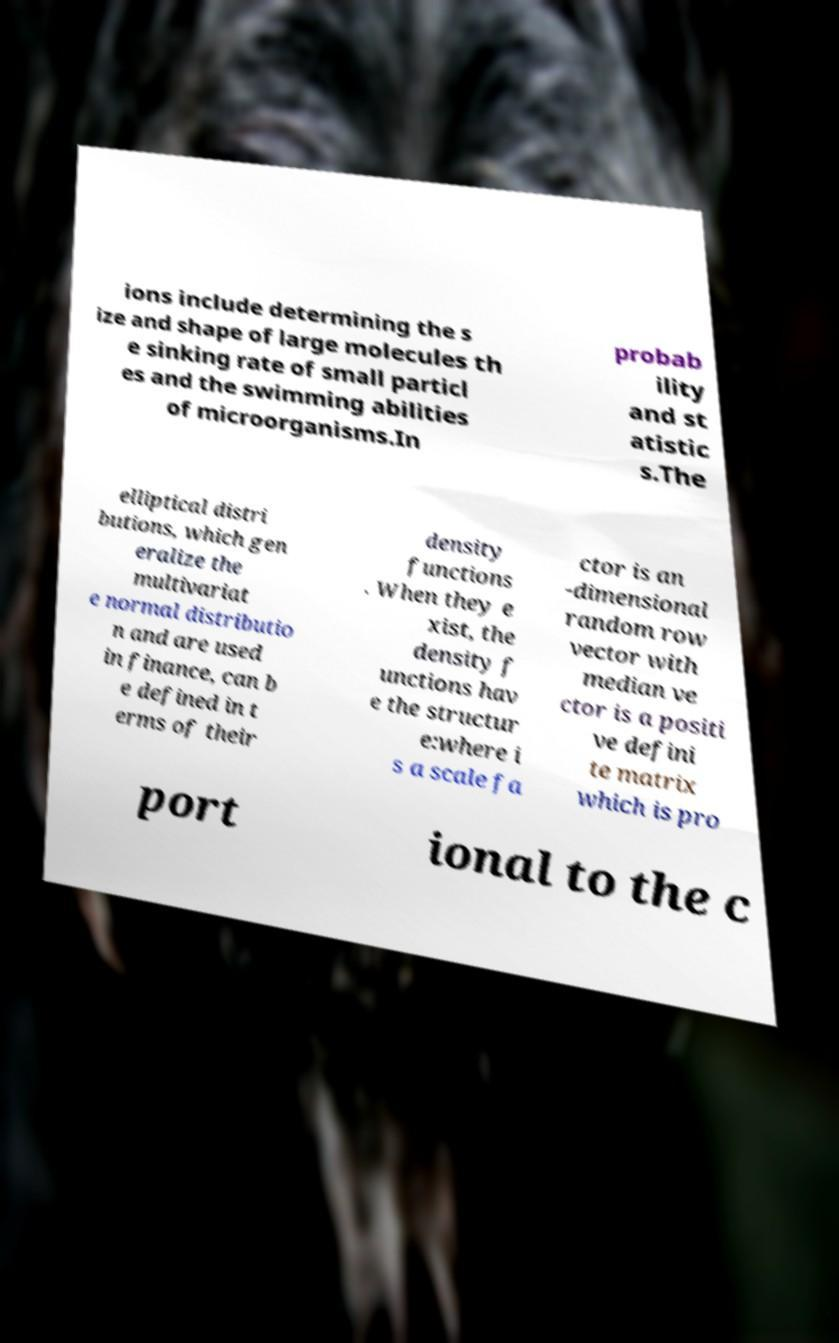Please read and relay the text visible in this image. What does it say? ions include determining the s ize and shape of large molecules th e sinking rate of small particl es and the swimming abilities of microorganisms.In probab ility and st atistic s.The elliptical distri butions, which gen eralize the multivariat e normal distributio n and are used in finance, can b e defined in t erms of their density functions . When they e xist, the density f unctions hav e the structur e:where i s a scale fa ctor is an -dimensional random row vector with median ve ctor is a positi ve defini te matrix which is pro port ional to the c 